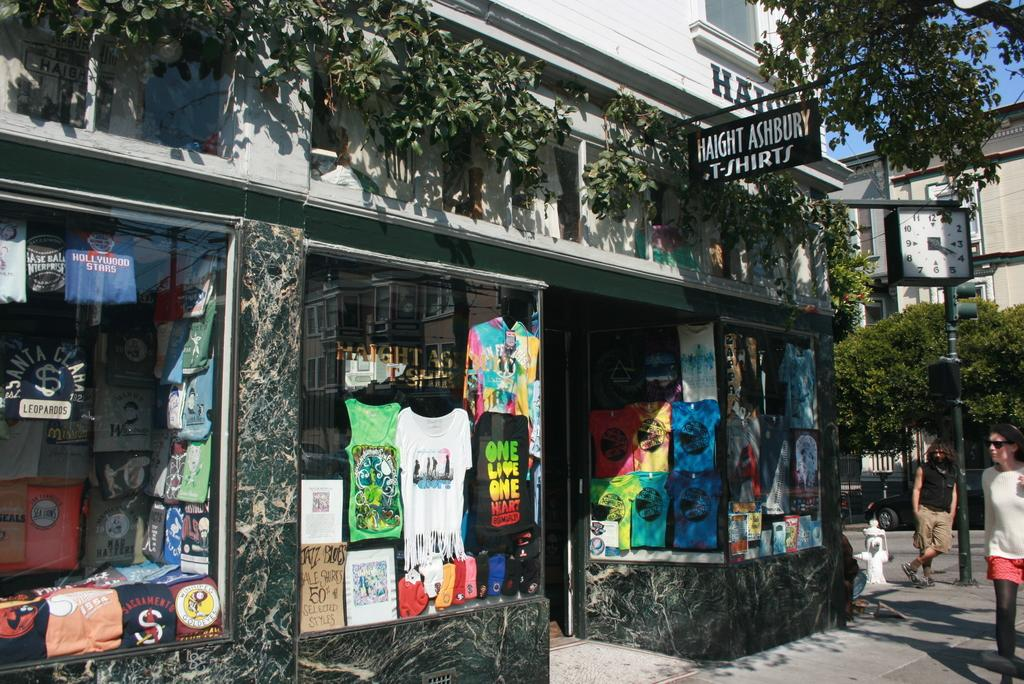How many people are in the image? There are two people in the image. What can be seen in the image besides the people? There is a traffic signal, a clock on a pole, glass, clothes visible through the glass, trees, a building, and the sky visible in the background of the image. What type of action are the chickens performing in the image? There are no chickens present in the image, so no such action can be observed. What type of breakfast is being served in the image? There is no breakfast visible in the image. 